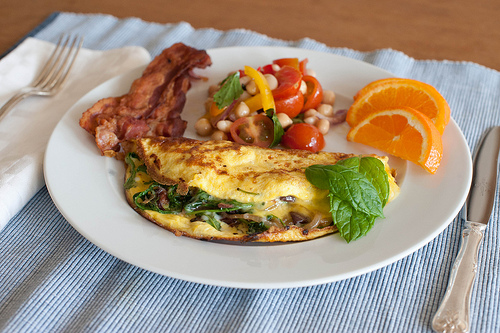<image>
Is there a plant leaf on the omelet? Yes. Looking at the image, I can see the plant leaf is positioned on top of the omelet, with the omelet providing support. 